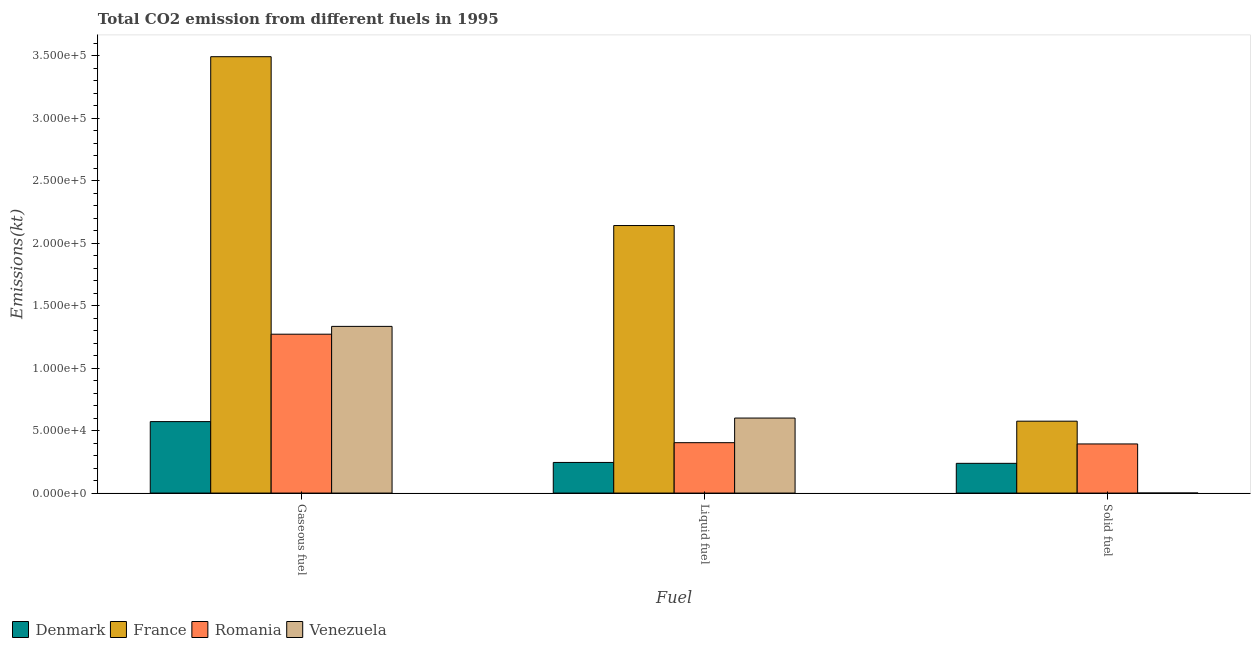Are the number of bars per tick equal to the number of legend labels?
Keep it short and to the point. Yes. Are the number of bars on each tick of the X-axis equal?
Give a very brief answer. Yes. What is the label of the 1st group of bars from the left?
Your answer should be compact. Gaseous fuel. What is the amount of co2 emissions from solid fuel in Romania?
Your answer should be very brief. 3.93e+04. Across all countries, what is the maximum amount of co2 emissions from solid fuel?
Your answer should be very brief. 5.75e+04. Across all countries, what is the minimum amount of co2 emissions from liquid fuel?
Offer a terse response. 2.45e+04. What is the total amount of co2 emissions from solid fuel in the graph?
Make the answer very short. 1.21e+05. What is the difference between the amount of co2 emissions from solid fuel in France and that in Venezuela?
Your answer should be compact. 5.75e+04. What is the difference between the amount of co2 emissions from liquid fuel in Romania and the amount of co2 emissions from solid fuel in Denmark?
Offer a very short reply. 1.65e+04. What is the average amount of co2 emissions from gaseous fuel per country?
Ensure brevity in your answer.  1.67e+05. What is the difference between the amount of co2 emissions from gaseous fuel and amount of co2 emissions from liquid fuel in Venezuela?
Offer a very short reply. 7.33e+04. In how many countries, is the amount of co2 emissions from solid fuel greater than 100000 kt?
Keep it short and to the point. 0. What is the ratio of the amount of co2 emissions from gaseous fuel in Romania to that in Venezuela?
Keep it short and to the point. 0.95. Is the amount of co2 emissions from gaseous fuel in Denmark less than that in Romania?
Your answer should be very brief. Yes. Is the difference between the amount of co2 emissions from gaseous fuel in Venezuela and Denmark greater than the difference between the amount of co2 emissions from liquid fuel in Venezuela and Denmark?
Offer a very short reply. Yes. What is the difference between the highest and the second highest amount of co2 emissions from solid fuel?
Offer a very short reply. 1.82e+04. What is the difference between the highest and the lowest amount of co2 emissions from gaseous fuel?
Your answer should be compact. 2.92e+05. What does the 4th bar from the left in Solid fuel represents?
Your answer should be compact. Venezuela. Is it the case that in every country, the sum of the amount of co2 emissions from gaseous fuel and amount of co2 emissions from liquid fuel is greater than the amount of co2 emissions from solid fuel?
Ensure brevity in your answer.  Yes. How many countries are there in the graph?
Give a very brief answer. 4. What is the difference between two consecutive major ticks on the Y-axis?
Ensure brevity in your answer.  5.00e+04. Does the graph contain any zero values?
Provide a short and direct response. No. Does the graph contain grids?
Your answer should be very brief. No. Where does the legend appear in the graph?
Your response must be concise. Bottom left. What is the title of the graph?
Offer a terse response. Total CO2 emission from different fuels in 1995. Does "East Asia (all income levels)" appear as one of the legend labels in the graph?
Keep it short and to the point. No. What is the label or title of the X-axis?
Your answer should be compact. Fuel. What is the label or title of the Y-axis?
Your answer should be compact. Emissions(kt). What is the Emissions(kt) of Denmark in Gaseous fuel?
Provide a succinct answer. 5.72e+04. What is the Emissions(kt) of France in Gaseous fuel?
Your answer should be very brief. 3.49e+05. What is the Emissions(kt) in Romania in Gaseous fuel?
Ensure brevity in your answer.  1.27e+05. What is the Emissions(kt) of Venezuela in Gaseous fuel?
Your answer should be compact. 1.33e+05. What is the Emissions(kt) of Denmark in Liquid fuel?
Your answer should be very brief. 2.45e+04. What is the Emissions(kt) of France in Liquid fuel?
Make the answer very short. 2.14e+05. What is the Emissions(kt) in Romania in Liquid fuel?
Offer a very short reply. 4.03e+04. What is the Emissions(kt) in Venezuela in Liquid fuel?
Make the answer very short. 6.00e+04. What is the Emissions(kt) of Denmark in Solid fuel?
Keep it short and to the point. 2.38e+04. What is the Emissions(kt) of France in Solid fuel?
Ensure brevity in your answer.  5.75e+04. What is the Emissions(kt) of Romania in Solid fuel?
Your response must be concise. 3.93e+04. What is the Emissions(kt) in Venezuela in Solid fuel?
Offer a terse response. 18.34. Across all Fuel, what is the maximum Emissions(kt) of Denmark?
Your answer should be compact. 5.72e+04. Across all Fuel, what is the maximum Emissions(kt) of France?
Provide a short and direct response. 3.49e+05. Across all Fuel, what is the maximum Emissions(kt) of Romania?
Keep it short and to the point. 1.27e+05. Across all Fuel, what is the maximum Emissions(kt) in Venezuela?
Your answer should be compact. 1.33e+05. Across all Fuel, what is the minimum Emissions(kt) of Denmark?
Your answer should be very brief. 2.38e+04. Across all Fuel, what is the minimum Emissions(kt) of France?
Your answer should be compact. 5.75e+04. Across all Fuel, what is the minimum Emissions(kt) in Romania?
Your answer should be compact. 3.93e+04. Across all Fuel, what is the minimum Emissions(kt) of Venezuela?
Make the answer very short. 18.34. What is the total Emissions(kt) in Denmark in the graph?
Provide a succinct answer. 1.05e+05. What is the total Emissions(kt) of France in the graph?
Keep it short and to the point. 6.21e+05. What is the total Emissions(kt) in Romania in the graph?
Your answer should be compact. 2.07e+05. What is the total Emissions(kt) in Venezuela in the graph?
Provide a short and direct response. 1.93e+05. What is the difference between the Emissions(kt) in Denmark in Gaseous fuel and that in Liquid fuel?
Offer a terse response. 3.27e+04. What is the difference between the Emissions(kt) in France in Gaseous fuel and that in Liquid fuel?
Keep it short and to the point. 1.35e+05. What is the difference between the Emissions(kt) in Romania in Gaseous fuel and that in Liquid fuel?
Your response must be concise. 8.68e+04. What is the difference between the Emissions(kt) of Venezuela in Gaseous fuel and that in Liquid fuel?
Your answer should be compact. 7.33e+04. What is the difference between the Emissions(kt) in Denmark in Gaseous fuel and that in Solid fuel?
Make the answer very short. 3.34e+04. What is the difference between the Emissions(kt) in France in Gaseous fuel and that in Solid fuel?
Ensure brevity in your answer.  2.92e+05. What is the difference between the Emissions(kt) in Romania in Gaseous fuel and that in Solid fuel?
Offer a terse response. 8.78e+04. What is the difference between the Emissions(kt) in Venezuela in Gaseous fuel and that in Solid fuel?
Provide a short and direct response. 1.33e+05. What is the difference between the Emissions(kt) in Denmark in Liquid fuel and that in Solid fuel?
Offer a terse response. 707.73. What is the difference between the Emissions(kt) of France in Liquid fuel and that in Solid fuel?
Ensure brevity in your answer.  1.57e+05. What is the difference between the Emissions(kt) of Romania in Liquid fuel and that in Solid fuel?
Offer a very short reply. 1015.76. What is the difference between the Emissions(kt) in Venezuela in Liquid fuel and that in Solid fuel?
Your response must be concise. 6.00e+04. What is the difference between the Emissions(kt) of Denmark in Gaseous fuel and the Emissions(kt) of France in Liquid fuel?
Provide a short and direct response. -1.57e+05. What is the difference between the Emissions(kt) in Denmark in Gaseous fuel and the Emissions(kt) in Romania in Liquid fuel?
Your response must be concise. 1.69e+04. What is the difference between the Emissions(kt) in Denmark in Gaseous fuel and the Emissions(kt) in Venezuela in Liquid fuel?
Provide a short and direct response. -2841.93. What is the difference between the Emissions(kt) of France in Gaseous fuel and the Emissions(kt) of Romania in Liquid fuel?
Provide a short and direct response. 3.09e+05. What is the difference between the Emissions(kt) in France in Gaseous fuel and the Emissions(kt) in Venezuela in Liquid fuel?
Your response must be concise. 2.89e+05. What is the difference between the Emissions(kt) of Romania in Gaseous fuel and the Emissions(kt) of Venezuela in Liquid fuel?
Your response must be concise. 6.71e+04. What is the difference between the Emissions(kt) in Denmark in Gaseous fuel and the Emissions(kt) in France in Solid fuel?
Your answer should be very brief. -344.7. What is the difference between the Emissions(kt) in Denmark in Gaseous fuel and the Emissions(kt) in Romania in Solid fuel?
Ensure brevity in your answer.  1.79e+04. What is the difference between the Emissions(kt) of Denmark in Gaseous fuel and the Emissions(kt) of Venezuela in Solid fuel?
Your answer should be compact. 5.72e+04. What is the difference between the Emissions(kt) in France in Gaseous fuel and the Emissions(kt) in Romania in Solid fuel?
Offer a terse response. 3.10e+05. What is the difference between the Emissions(kt) in France in Gaseous fuel and the Emissions(kt) in Venezuela in Solid fuel?
Keep it short and to the point. 3.49e+05. What is the difference between the Emissions(kt) of Romania in Gaseous fuel and the Emissions(kt) of Venezuela in Solid fuel?
Make the answer very short. 1.27e+05. What is the difference between the Emissions(kt) of Denmark in Liquid fuel and the Emissions(kt) of France in Solid fuel?
Your response must be concise. -3.30e+04. What is the difference between the Emissions(kt) in Denmark in Liquid fuel and the Emissions(kt) in Romania in Solid fuel?
Your answer should be very brief. -1.48e+04. What is the difference between the Emissions(kt) in Denmark in Liquid fuel and the Emissions(kt) in Venezuela in Solid fuel?
Your answer should be compact. 2.45e+04. What is the difference between the Emissions(kt) in France in Liquid fuel and the Emissions(kt) in Romania in Solid fuel?
Give a very brief answer. 1.75e+05. What is the difference between the Emissions(kt) in France in Liquid fuel and the Emissions(kt) in Venezuela in Solid fuel?
Your answer should be very brief. 2.14e+05. What is the difference between the Emissions(kt) in Romania in Liquid fuel and the Emissions(kt) in Venezuela in Solid fuel?
Provide a succinct answer. 4.03e+04. What is the average Emissions(kt) in Denmark per Fuel?
Give a very brief answer. 3.52e+04. What is the average Emissions(kt) in France per Fuel?
Offer a terse response. 2.07e+05. What is the average Emissions(kt) of Romania per Fuel?
Your answer should be compact. 6.89e+04. What is the average Emissions(kt) in Venezuela per Fuel?
Offer a terse response. 6.45e+04. What is the difference between the Emissions(kt) of Denmark and Emissions(kt) of France in Gaseous fuel?
Make the answer very short. -2.92e+05. What is the difference between the Emissions(kt) in Denmark and Emissions(kt) in Romania in Gaseous fuel?
Your answer should be compact. -6.99e+04. What is the difference between the Emissions(kt) in Denmark and Emissions(kt) in Venezuela in Gaseous fuel?
Your response must be concise. -7.62e+04. What is the difference between the Emissions(kt) of France and Emissions(kt) of Romania in Gaseous fuel?
Your response must be concise. 2.22e+05. What is the difference between the Emissions(kt) in France and Emissions(kt) in Venezuela in Gaseous fuel?
Offer a very short reply. 2.16e+05. What is the difference between the Emissions(kt) of Romania and Emissions(kt) of Venezuela in Gaseous fuel?
Provide a succinct answer. -6248.57. What is the difference between the Emissions(kt) in Denmark and Emissions(kt) in France in Liquid fuel?
Your answer should be compact. -1.90e+05. What is the difference between the Emissions(kt) of Denmark and Emissions(kt) of Romania in Liquid fuel?
Make the answer very short. -1.58e+04. What is the difference between the Emissions(kt) in Denmark and Emissions(kt) in Venezuela in Liquid fuel?
Offer a very short reply. -3.55e+04. What is the difference between the Emissions(kt) of France and Emissions(kt) of Romania in Liquid fuel?
Make the answer very short. 1.74e+05. What is the difference between the Emissions(kt) in France and Emissions(kt) in Venezuela in Liquid fuel?
Keep it short and to the point. 1.54e+05. What is the difference between the Emissions(kt) of Romania and Emissions(kt) of Venezuela in Liquid fuel?
Keep it short and to the point. -1.97e+04. What is the difference between the Emissions(kt) of Denmark and Emissions(kt) of France in Solid fuel?
Give a very brief answer. -3.37e+04. What is the difference between the Emissions(kt) of Denmark and Emissions(kt) of Romania in Solid fuel?
Offer a terse response. -1.55e+04. What is the difference between the Emissions(kt) in Denmark and Emissions(kt) in Venezuela in Solid fuel?
Keep it short and to the point. 2.38e+04. What is the difference between the Emissions(kt) of France and Emissions(kt) of Romania in Solid fuel?
Your answer should be very brief. 1.82e+04. What is the difference between the Emissions(kt) in France and Emissions(kt) in Venezuela in Solid fuel?
Provide a short and direct response. 5.75e+04. What is the difference between the Emissions(kt) in Romania and Emissions(kt) in Venezuela in Solid fuel?
Your response must be concise. 3.93e+04. What is the ratio of the Emissions(kt) in Denmark in Gaseous fuel to that in Liquid fuel?
Make the answer very short. 2.33. What is the ratio of the Emissions(kt) in France in Gaseous fuel to that in Liquid fuel?
Offer a terse response. 1.63. What is the ratio of the Emissions(kt) in Romania in Gaseous fuel to that in Liquid fuel?
Provide a succinct answer. 3.15. What is the ratio of the Emissions(kt) of Venezuela in Gaseous fuel to that in Liquid fuel?
Give a very brief answer. 2.22. What is the ratio of the Emissions(kt) of Denmark in Gaseous fuel to that in Solid fuel?
Give a very brief answer. 2.4. What is the ratio of the Emissions(kt) in France in Gaseous fuel to that in Solid fuel?
Give a very brief answer. 6.07. What is the ratio of the Emissions(kt) of Romania in Gaseous fuel to that in Solid fuel?
Your answer should be compact. 3.23. What is the ratio of the Emissions(kt) of Venezuela in Gaseous fuel to that in Solid fuel?
Provide a succinct answer. 7273. What is the ratio of the Emissions(kt) in Denmark in Liquid fuel to that in Solid fuel?
Ensure brevity in your answer.  1.03. What is the ratio of the Emissions(kt) in France in Liquid fuel to that in Solid fuel?
Offer a very short reply. 3.72. What is the ratio of the Emissions(kt) of Romania in Liquid fuel to that in Solid fuel?
Keep it short and to the point. 1.03. What is the ratio of the Emissions(kt) in Venezuela in Liquid fuel to that in Solid fuel?
Provide a short and direct response. 3273.2. What is the difference between the highest and the second highest Emissions(kt) of Denmark?
Keep it short and to the point. 3.27e+04. What is the difference between the highest and the second highest Emissions(kt) of France?
Your answer should be compact. 1.35e+05. What is the difference between the highest and the second highest Emissions(kt) in Romania?
Your answer should be very brief. 8.68e+04. What is the difference between the highest and the second highest Emissions(kt) in Venezuela?
Give a very brief answer. 7.33e+04. What is the difference between the highest and the lowest Emissions(kt) in Denmark?
Make the answer very short. 3.34e+04. What is the difference between the highest and the lowest Emissions(kt) of France?
Keep it short and to the point. 2.92e+05. What is the difference between the highest and the lowest Emissions(kt) of Romania?
Ensure brevity in your answer.  8.78e+04. What is the difference between the highest and the lowest Emissions(kt) of Venezuela?
Your answer should be compact. 1.33e+05. 